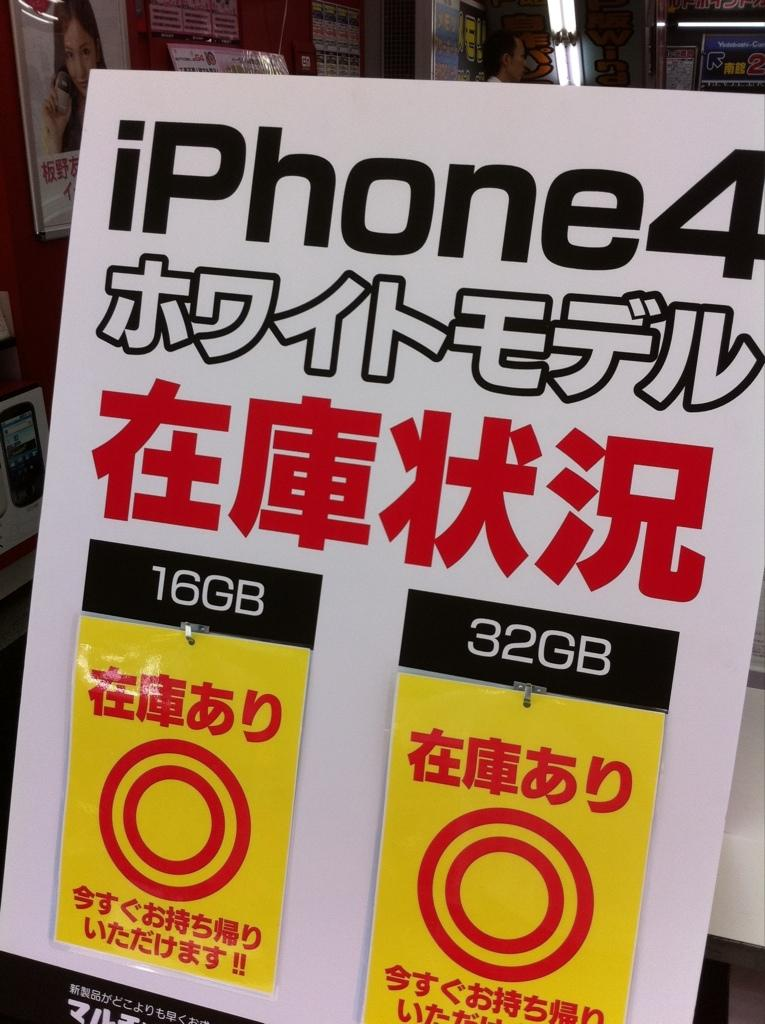<image>
Offer a succinct explanation of the picture presented. iPhone4 poster advertisement selling the 16GB and 32GB 